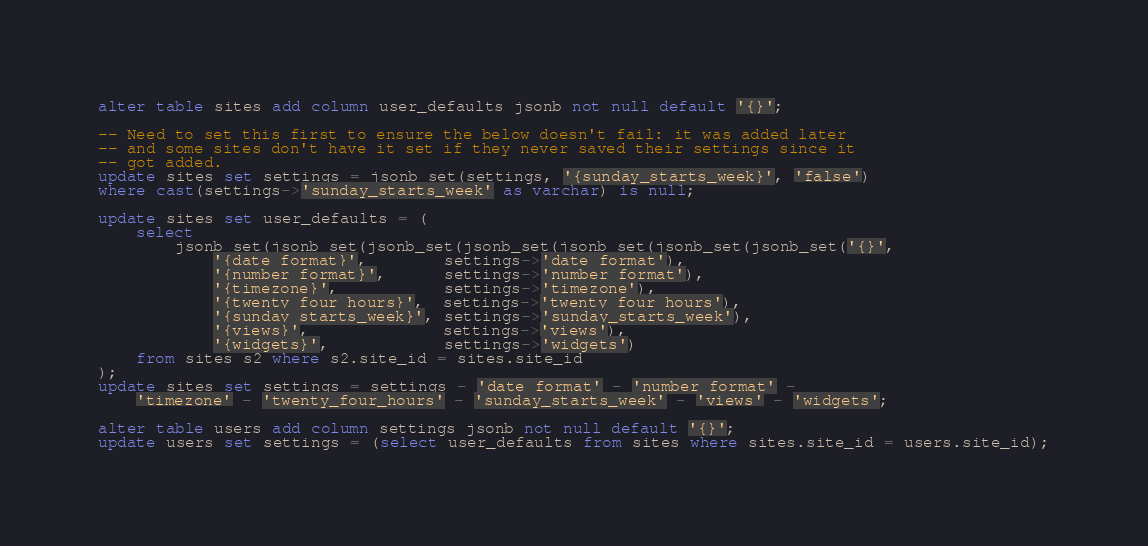Convert code to text. <code><loc_0><loc_0><loc_500><loc_500><_SQL_>alter table sites add column user_defaults jsonb not null default '{}';

-- Need to set this first to ensure the below doesn't fail: it was added later
-- and some sites don't have it set if they never saved their settings since it
-- got added.
update sites set settings = jsonb_set(settings, '{sunday_starts_week}', 'false')
where cast(settings->'sunday_starts_week' as varchar) is null;

update sites set user_defaults = (
    select
        jsonb_set(jsonb_set(jsonb_set(jsonb_set(jsonb_set(jsonb_set(jsonb_set('{}',
            '{date_format}',        settings->'date_format'),
            '{number_format}',      settings->'number_format'),
            '{timezone}',           settings->'timezone'),
            '{twenty_four_hours}',  settings->'twenty_four_hours'),
            '{sunday_starts_week}', settings->'sunday_starts_week'),
            '{views}',              settings->'views'),
            '{widgets}',            settings->'widgets')
    from sites s2 where s2.site_id = sites.site_id
);
update sites set settings = settings - 'date_format' - 'number_format' -
	'timezone' - 'twenty_four_hours' - 'sunday_starts_week' - 'views' - 'widgets';

alter table users add column settings jsonb not null default '{}';
update users set settings = (select user_defaults from sites where sites.site_id = users.site_id);
</code> 